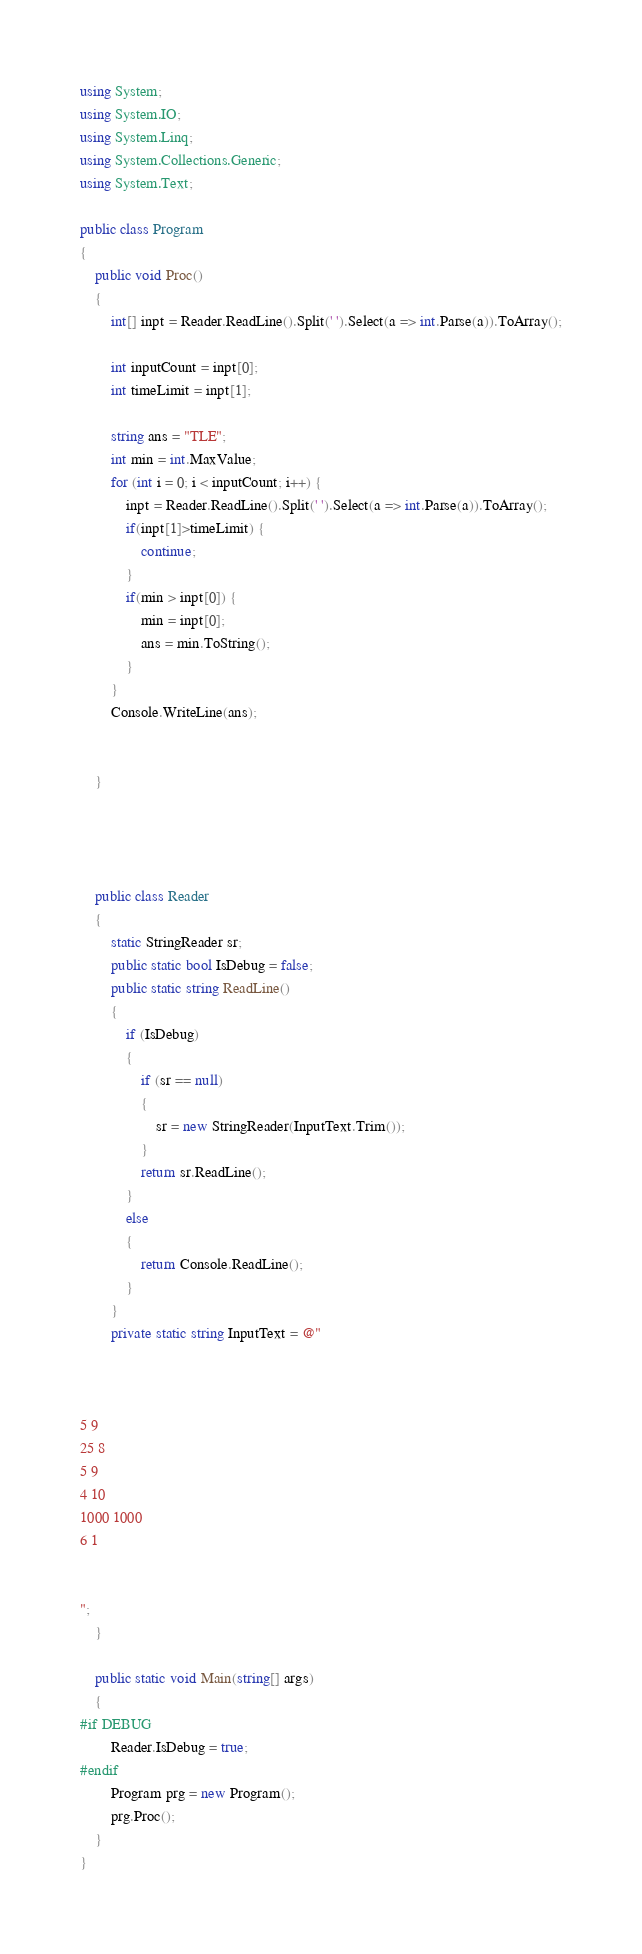Convert code to text. <code><loc_0><loc_0><loc_500><loc_500><_C#_>using System;
using System.IO;
using System.Linq;
using System.Collections.Generic;
using System.Text;

public class Program
{
    public void Proc()
    {
        int[] inpt = Reader.ReadLine().Split(' ').Select(a => int.Parse(a)).ToArray();

        int inputCount = inpt[0];
        int timeLimit = inpt[1];

        string ans = "TLE";
        int min = int.MaxValue;
        for (int i = 0; i < inputCount; i++) {
            inpt = Reader.ReadLine().Split(' ').Select(a => int.Parse(a)).ToArray();
            if(inpt[1]>timeLimit) {
                continue;
            }
            if(min > inpt[0]) {
                min = inpt[0];
                ans = min.ToString();
            }
        }
        Console.WriteLine(ans);


    }




    public class Reader
    {
        static StringReader sr;
        public static bool IsDebug = false;
        public static string ReadLine()
        {
            if (IsDebug)
            {
                if (sr == null)
                {
                    sr = new StringReader(InputText.Trim());
                }
                return sr.ReadLine();
            }
            else
            {
                return Console.ReadLine();
            }
        }
        private static string InputText = @"



5 9
25 8
5 9
4 10
1000 1000
6 1


";
    }

    public static void Main(string[] args)
    {
#if DEBUG
        Reader.IsDebug = true;
#endif
        Program prg = new Program();
        prg.Proc();
    }
}
</code> 